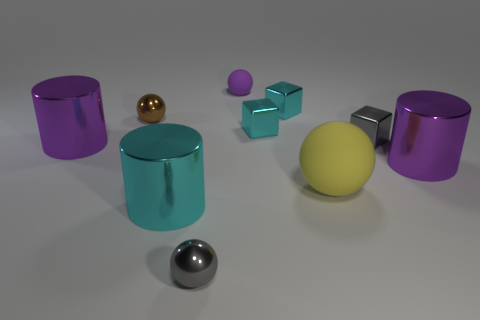Subtract all cyan cylinders. How many cylinders are left? 2 Subtract all gray metallic spheres. How many spheres are left? 3 Subtract 2 blocks. How many blocks are left? 1 Subtract all cyan spheres. Subtract all yellow cubes. How many spheres are left? 4 Subtract all purple balls. How many yellow cylinders are left? 0 Subtract all yellow rubber objects. Subtract all tiny brown balls. How many objects are left? 8 Add 6 tiny gray cubes. How many tiny gray cubes are left? 7 Add 9 brown metal objects. How many brown metal objects exist? 10 Subtract 1 purple cylinders. How many objects are left? 9 Subtract all balls. How many objects are left? 6 